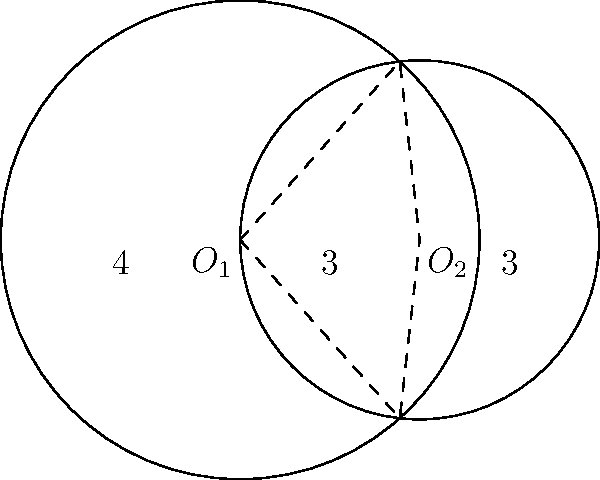In the diagram, two circles with radii 4 and 3 units intersect. The centers of the circles are 3 units apart. Calculate the area of the region bounded by both circles (i.e., the lens-shaped region formed by the intersection). Express your answer in terms of π and round to two decimal places. To solve this problem, we'll use the formula for the area of intersection of two circles. Let's approach this step-by-step:

1) First, we need to find the angle θ at the center of each circle formed by the radii to the points of intersection.

   For the larger circle (radius 4):
   $$\cos(\theta_1/2) = \frac{3}{8}$$
   $$\theta_1 = 2 \arccos(\frac{3}{8}) = 2.498 \text{ radians}$$

   For the smaller circle (radius 3):
   $$\cos(\theta_2/2) = \frac{3}{6} = \frac{1}{2}$$
   $$\theta_2 = 2 \arccos(\frac{1}{2}) = 2.094 \text{ radians}$$

2) The area of the lens-shaped region is the sum of the areas of the two circular segments minus the area of the rhombus formed by the radii.

3) Area of a circular segment = $r^2(\theta - \sin(\theta))/2$

   For the larger circle: $A_1 = 4^2(2.498 - \sin(2.498))/2 = 6.475$
   For the smaller circle: $A_2 = 3^2(2.094 - \sin(2.094))/2 = 2.858$

4) Area of the rhombus = $3 \times 4 \sin(\theta_1/2) = 9.165$

5) Total area = $A_1 + A_2 - 9.165 = 6.475 + 2.858 - 9.165 = 0.168$

6) This area is in square units. To express it in terms of π, we divide by π:

   $0.168 / π ≈ 0.05$

Therefore, the area of the lens-shaped region is approximately $0.05π$ square units.
Answer: $0.05π$ square units 